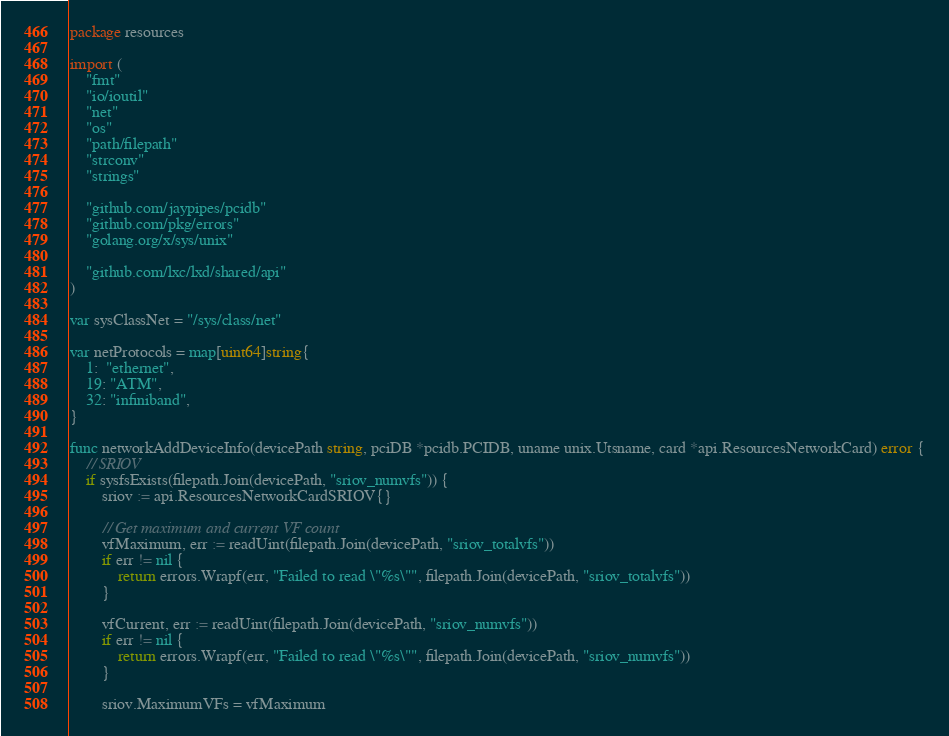<code> <loc_0><loc_0><loc_500><loc_500><_Go_>package resources

import (
	"fmt"
	"io/ioutil"
	"net"
	"os"
	"path/filepath"
	"strconv"
	"strings"

	"github.com/jaypipes/pcidb"
	"github.com/pkg/errors"
	"golang.org/x/sys/unix"

	"github.com/lxc/lxd/shared/api"
)

var sysClassNet = "/sys/class/net"

var netProtocols = map[uint64]string{
	1:  "ethernet",
	19: "ATM",
	32: "infiniband",
}

func networkAddDeviceInfo(devicePath string, pciDB *pcidb.PCIDB, uname unix.Utsname, card *api.ResourcesNetworkCard) error {
	// SRIOV
	if sysfsExists(filepath.Join(devicePath, "sriov_numvfs")) {
		sriov := api.ResourcesNetworkCardSRIOV{}

		// Get maximum and current VF count
		vfMaximum, err := readUint(filepath.Join(devicePath, "sriov_totalvfs"))
		if err != nil {
			return errors.Wrapf(err, "Failed to read \"%s\"", filepath.Join(devicePath, "sriov_totalvfs"))
		}

		vfCurrent, err := readUint(filepath.Join(devicePath, "sriov_numvfs"))
		if err != nil {
			return errors.Wrapf(err, "Failed to read \"%s\"", filepath.Join(devicePath, "sriov_numvfs"))
		}

		sriov.MaximumVFs = vfMaximum</code> 